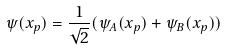Convert formula to latex. <formula><loc_0><loc_0><loc_500><loc_500>\psi ( x _ { p } ) = \frac { 1 } { \sqrt { 2 } } ( \psi _ { A } ( x _ { p } ) + \psi _ { B } ( x _ { p } ) )</formula> 